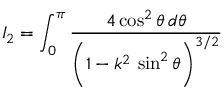Convert formula to latex. <formula><loc_0><loc_0><loc_500><loc_500>I _ { 2 } = \int _ { 0 } ^ { \pi } \frac { 4 \cos ^ { 2 } \theta \, d \theta } { \left ( 1 - k ^ { 2 } \, \sin ^ { 2 } \theta \right ) ^ { 3 / 2 } }</formula> 